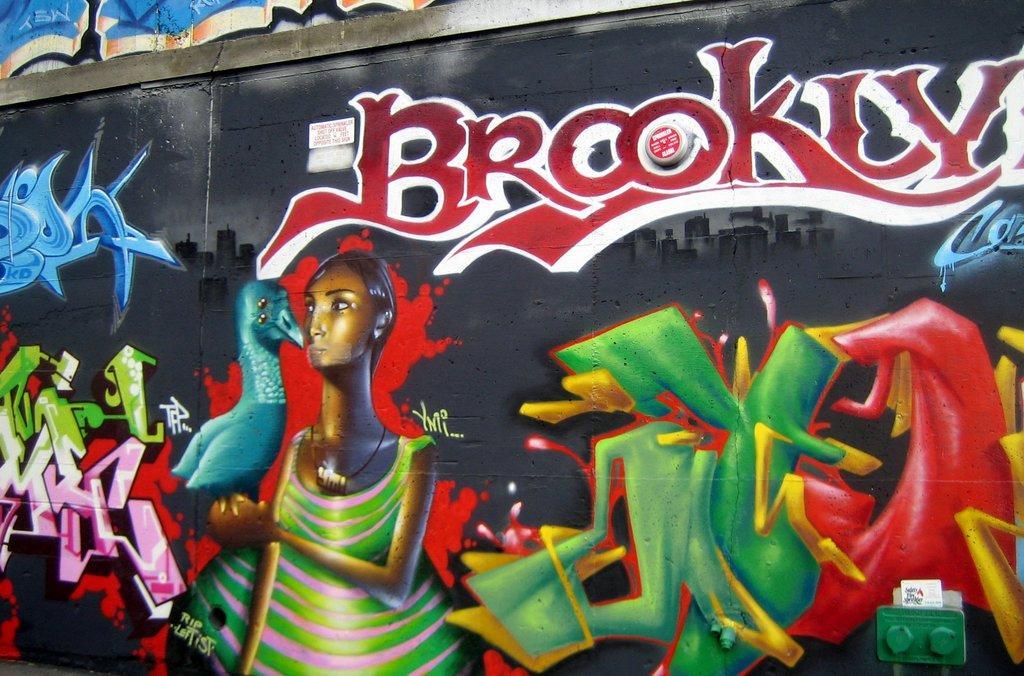Describe this image in one or two sentences. In this image we can see graffiti on the wall, there are images, and text on it, also we can see an object on the wall. 